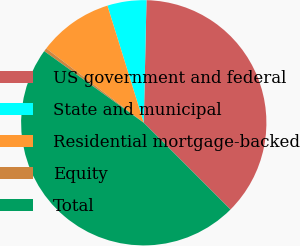Convert chart to OTSL. <chart><loc_0><loc_0><loc_500><loc_500><pie_chart><fcel>US government and federal<fcel>State and municipal<fcel>Residential mortgage-backed<fcel>Equity<fcel>Total<nl><fcel>37.15%<fcel>5.14%<fcel>9.84%<fcel>0.45%<fcel>47.42%<nl></chart> 